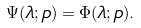<formula> <loc_0><loc_0><loc_500><loc_500>\Psi ( \lambda ; p ) = \Phi ( \lambda ; p ) .</formula> 